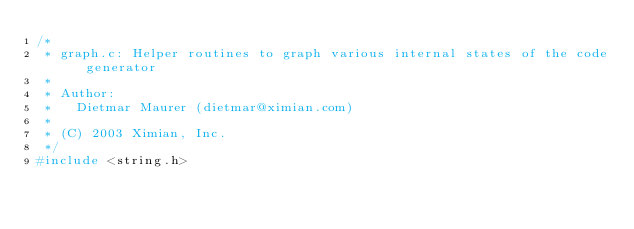<code> <loc_0><loc_0><loc_500><loc_500><_C_>/*
 * graph.c: Helper routines to graph various internal states of the code generator
 *
 * Author:
 *   Dietmar Maurer (dietmar@ximian.com)
 *
 * (C) 2003 Ximian, Inc.
 */
#include <string.h></code> 